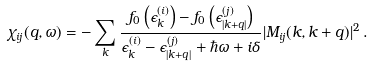<formula> <loc_0><loc_0><loc_500><loc_500>\chi _ { i j } ( q , \omega ) = - \sum _ { k } \frac { f _ { 0 } \left ( \epsilon _ { k } ^ { ( i ) } \right ) - f _ { 0 } \left ( \epsilon _ { | { k } + { q } | } ^ { ( j ) } \right ) } { \epsilon _ { k } ^ { ( i ) } - \epsilon _ { | { k } + { q } | } ^ { ( j ) } + \hbar { \omega } + i \delta } | M _ { i j } ( { k } , { k } + { q } ) | ^ { 2 } \, .</formula> 